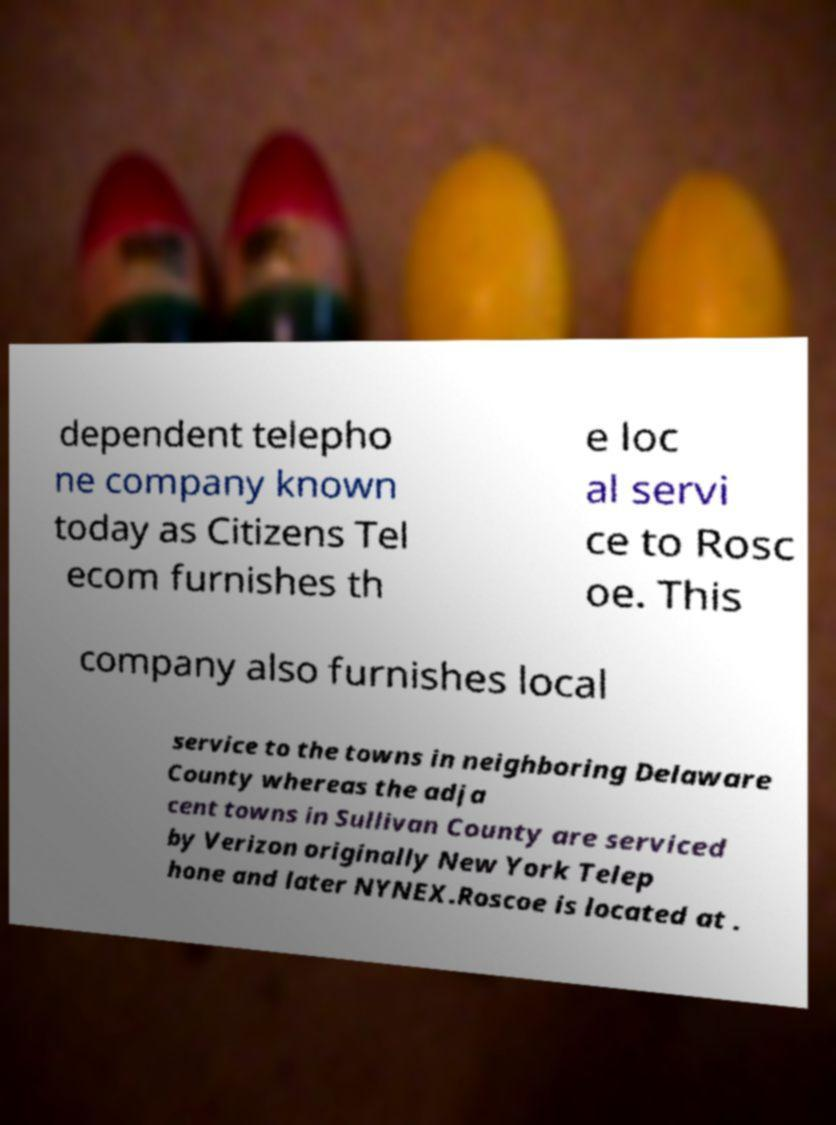There's text embedded in this image that I need extracted. Can you transcribe it verbatim? dependent telepho ne company known today as Citizens Tel ecom furnishes th e loc al servi ce to Rosc oe. This company also furnishes local service to the towns in neighboring Delaware County whereas the adja cent towns in Sullivan County are serviced by Verizon originally New York Telep hone and later NYNEX.Roscoe is located at . 